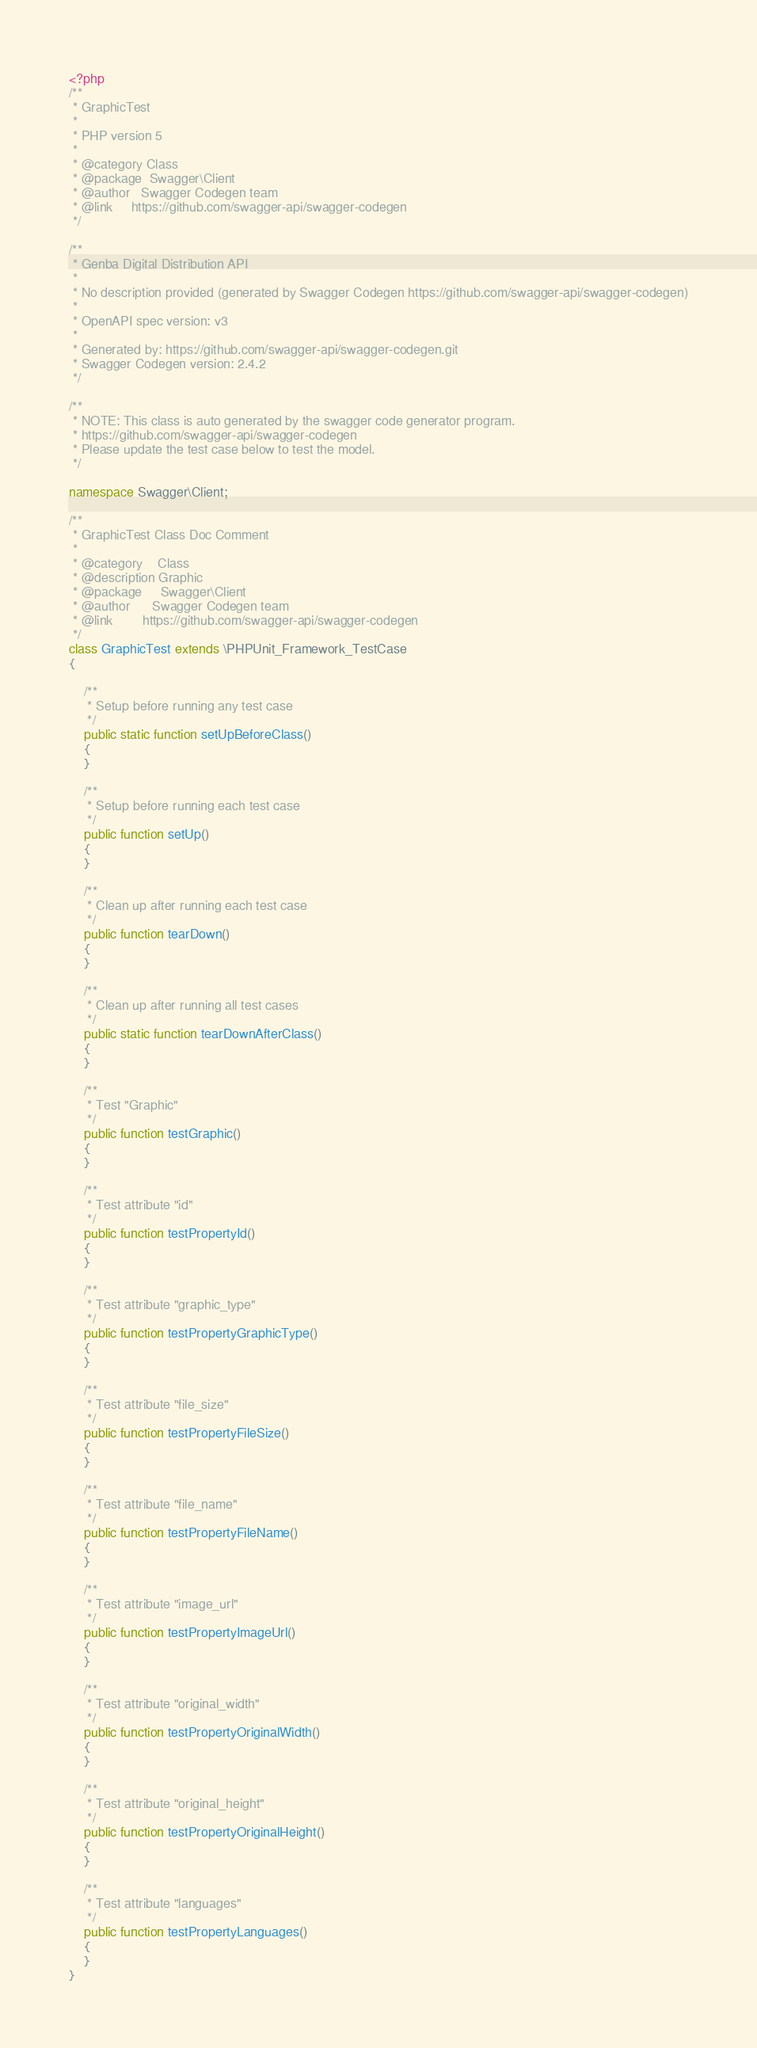Convert code to text. <code><loc_0><loc_0><loc_500><loc_500><_PHP_><?php
/**
 * GraphicTest
 *
 * PHP version 5
 *
 * @category Class
 * @package  Swagger\Client
 * @author   Swagger Codegen team
 * @link     https://github.com/swagger-api/swagger-codegen
 */

/**
 * Genba Digital Distribution API
 *
 * No description provided (generated by Swagger Codegen https://github.com/swagger-api/swagger-codegen)
 *
 * OpenAPI spec version: v3
 * 
 * Generated by: https://github.com/swagger-api/swagger-codegen.git
 * Swagger Codegen version: 2.4.2
 */

/**
 * NOTE: This class is auto generated by the swagger code generator program.
 * https://github.com/swagger-api/swagger-codegen
 * Please update the test case below to test the model.
 */

namespace Swagger\Client;

/**
 * GraphicTest Class Doc Comment
 *
 * @category    Class
 * @description Graphic
 * @package     Swagger\Client
 * @author      Swagger Codegen team
 * @link        https://github.com/swagger-api/swagger-codegen
 */
class GraphicTest extends \PHPUnit_Framework_TestCase
{

    /**
     * Setup before running any test case
     */
    public static function setUpBeforeClass()
    {
    }

    /**
     * Setup before running each test case
     */
    public function setUp()
    {
    }

    /**
     * Clean up after running each test case
     */
    public function tearDown()
    {
    }

    /**
     * Clean up after running all test cases
     */
    public static function tearDownAfterClass()
    {
    }

    /**
     * Test "Graphic"
     */
    public function testGraphic()
    {
    }

    /**
     * Test attribute "id"
     */
    public function testPropertyId()
    {
    }

    /**
     * Test attribute "graphic_type"
     */
    public function testPropertyGraphicType()
    {
    }

    /**
     * Test attribute "file_size"
     */
    public function testPropertyFileSize()
    {
    }

    /**
     * Test attribute "file_name"
     */
    public function testPropertyFileName()
    {
    }

    /**
     * Test attribute "image_url"
     */
    public function testPropertyImageUrl()
    {
    }

    /**
     * Test attribute "original_width"
     */
    public function testPropertyOriginalWidth()
    {
    }

    /**
     * Test attribute "original_height"
     */
    public function testPropertyOriginalHeight()
    {
    }

    /**
     * Test attribute "languages"
     */
    public function testPropertyLanguages()
    {
    }
}
</code> 